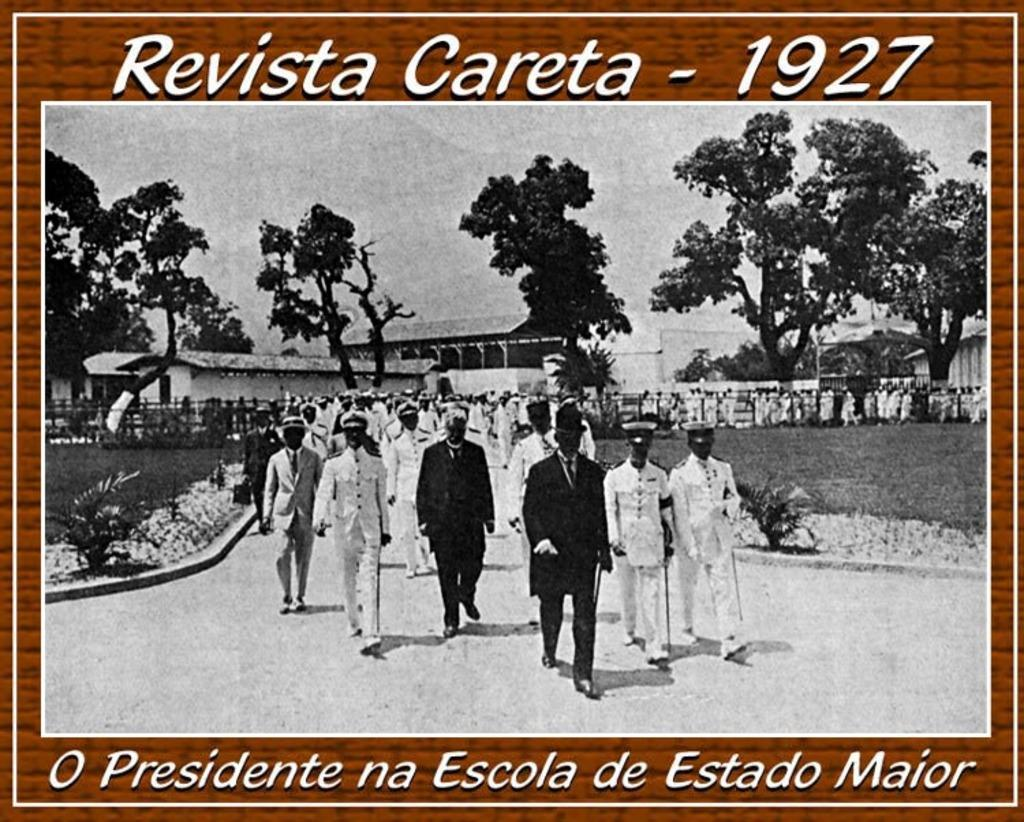Provide a one-sentence caption for the provided image. The image says Revista Careta - 1927 above a photo of a large procession of military personnel. 